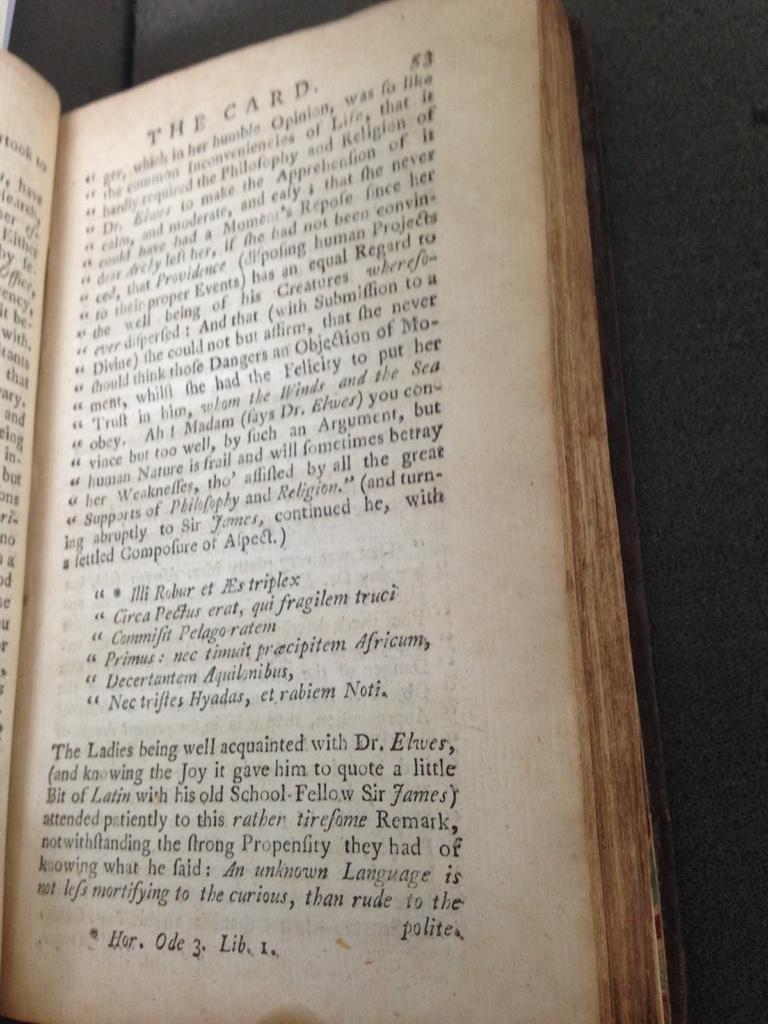<image>
Describe the image concisely. Book that shows about The Card on page fifty three. 